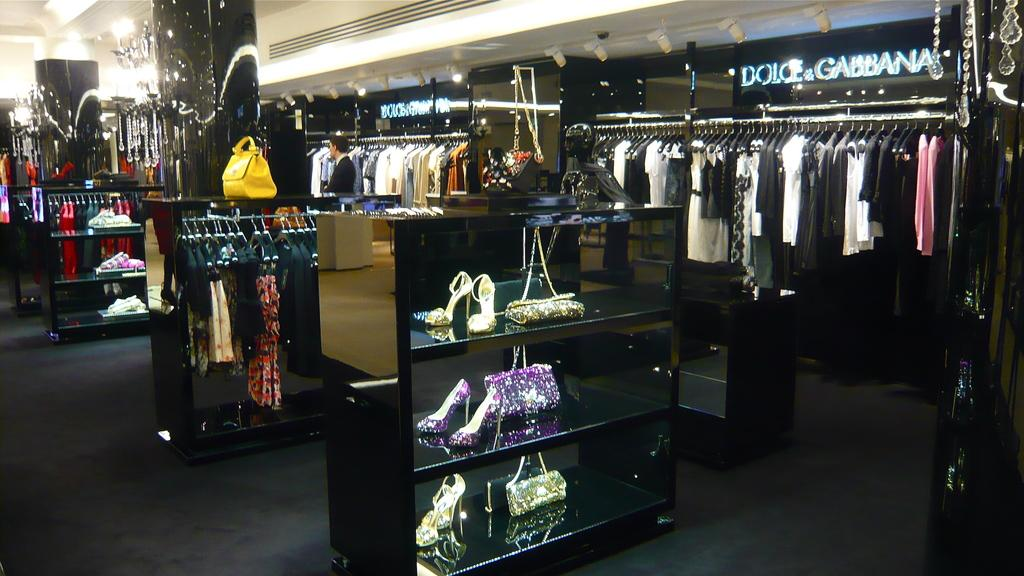<image>
Summarize the visual content of the image. A lot of clothes that are in a Dolce & Gabbana section of a store. 